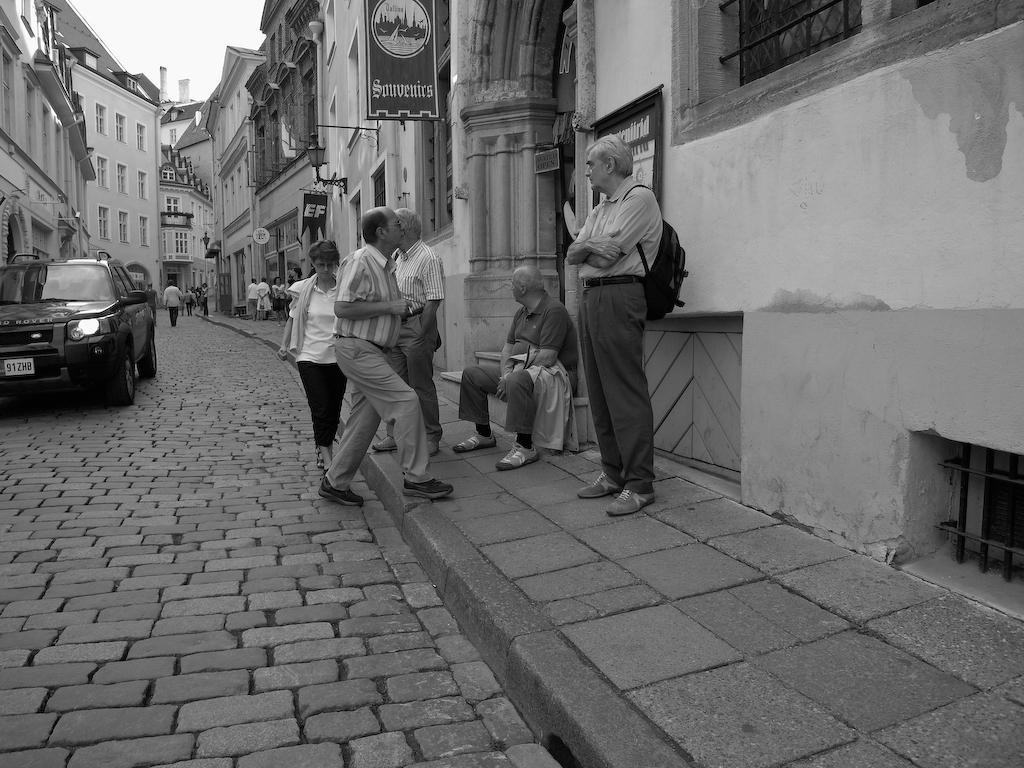What are the people in the image doing? The people in the image are standing. What is the man in the image doing? The man in the image is sitting. What can be seen on the left side of the image? There is a car on the left side of the image. What type of structures are visible in the image? There are buildings visible in the image. What type of waves can be seen crashing on the shore in the image? There are no waves or shore visible in the image; it features people, a sitting man, a car, and buildings. What instrument is the man playing in the image? The man in the image is sitting, but there is no indication that he is playing an instrument. 